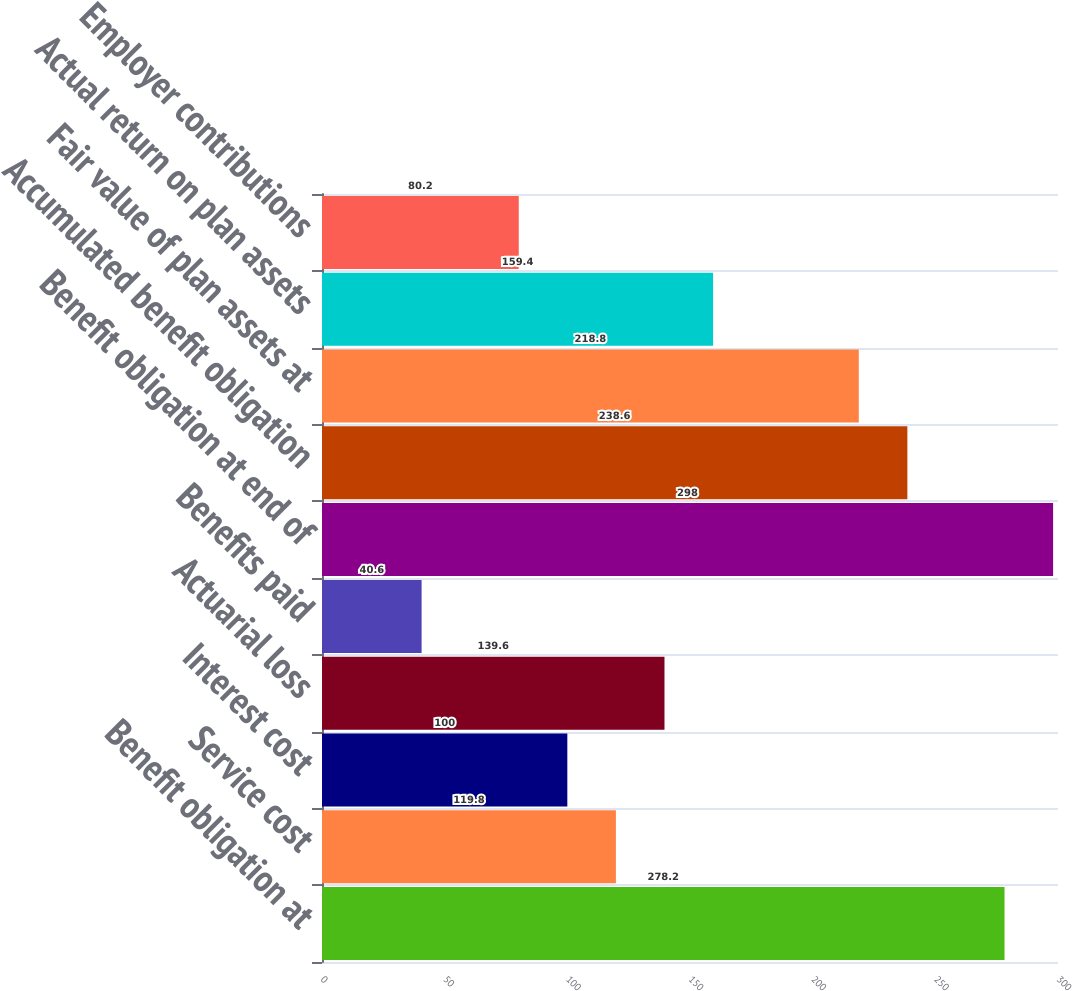<chart> <loc_0><loc_0><loc_500><loc_500><bar_chart><fcel>Benefit obligation at<fcel>Service cost<fcel>Interest cost<fcel>Actuarial loss<fcel>Benefits paid<fcel>Benefit obligation at end of<fcel>Accumulated benefit obligation<fcel>Fair value of plan assets at<fcel>Actual return on plan assets<fcel>Employer contributions<nl><fcel>278.2<fcel>119.8<fcel>100<fcel>139.6<fcel>40.6<fcel>298<fcel>238.6<fcel>218.8<fcel>159.4<fcel>80.2<nl></chart> 